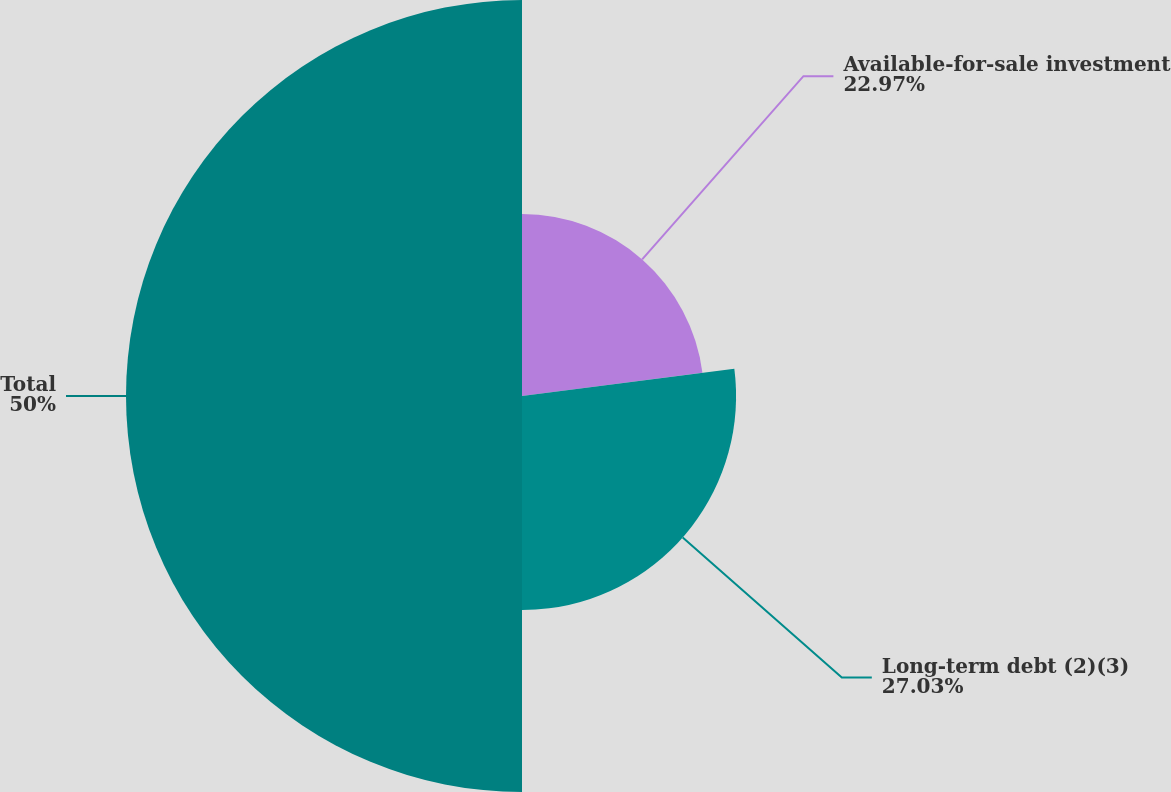Convert chart. <chart><loc_0><loc_0><loc_500><loc_500><pie_chart><fcel>Available-for-sale investment<fcel>Long-term debt (2)(3)<fcel>Total<nl><fcel>22.97%<fcel>27.03%<fcel>50.0%<nl></chart> 